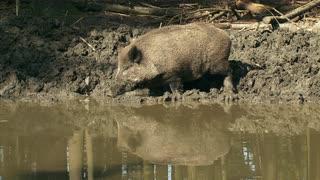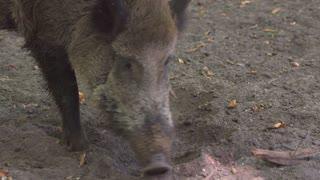The first image is the image on the left, the second image is the image on the right. For the images shown, is this caption "One of the wild pigs is standing in profile, and the other pig is standing with its snout aimed forward." true? Answer yes or no. Yes. The first image is the image on the left, the second image is the image on the right. For the images displayed, is the sentence "A pig is walking in the snow." factually correct? Answer yes or no. No. 